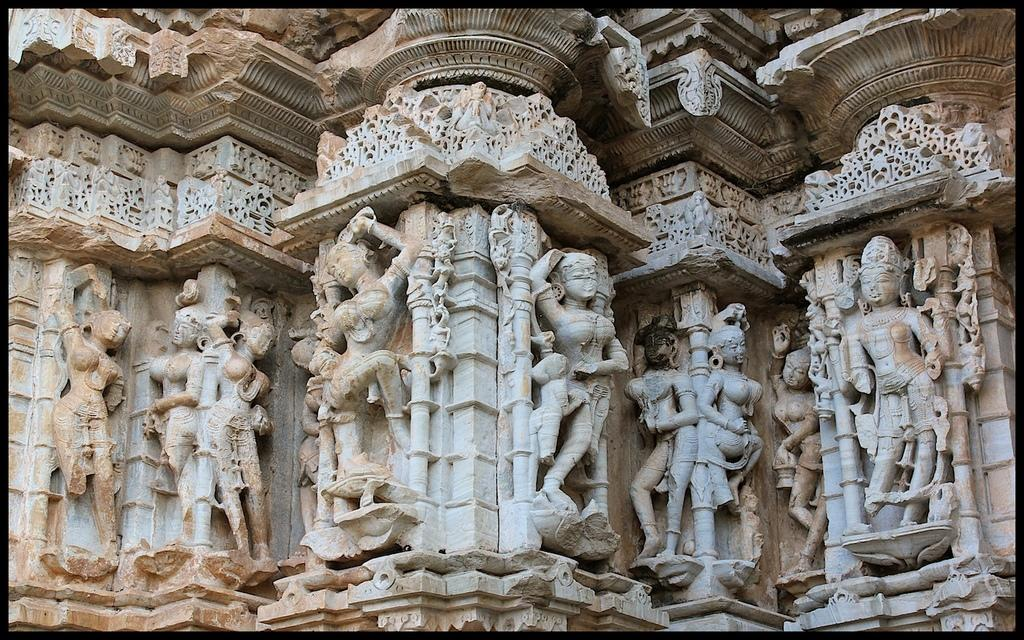What is depicted on the wall in the image? There are statues on the wall in the image. What type of apparel is the baby wearing in the crib in the image? There is no baby or crib present in the image; it only features statues on the wall. 